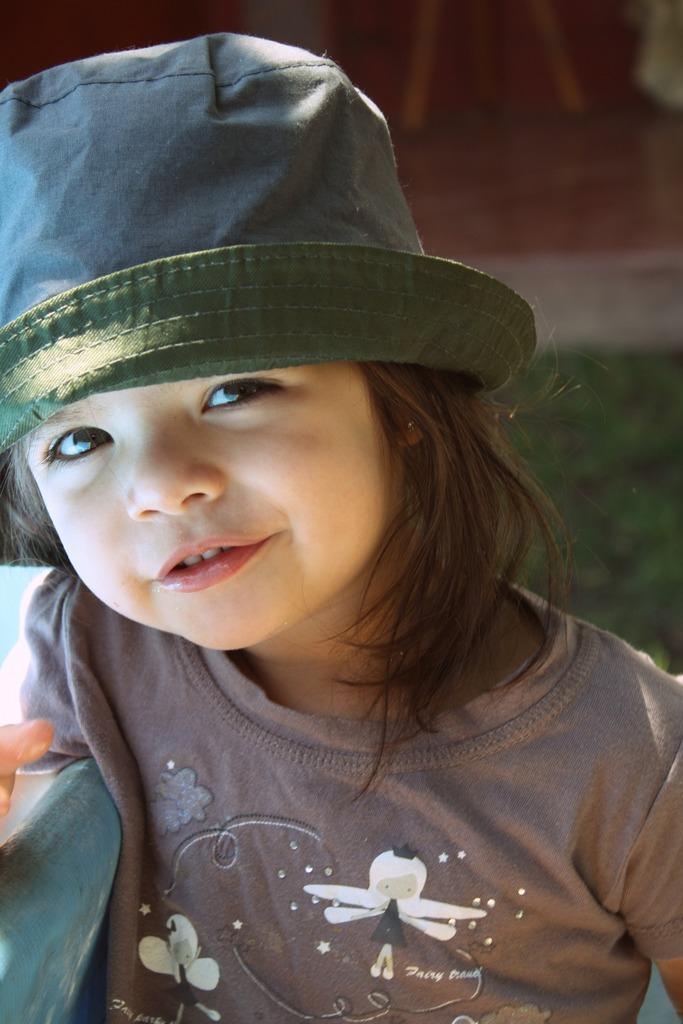Could you give a brief overview of what you see in this image? In the image we can see there is a girl and she is wearing hat. Behind there is grass on the ground and background of the image is little blurred. 